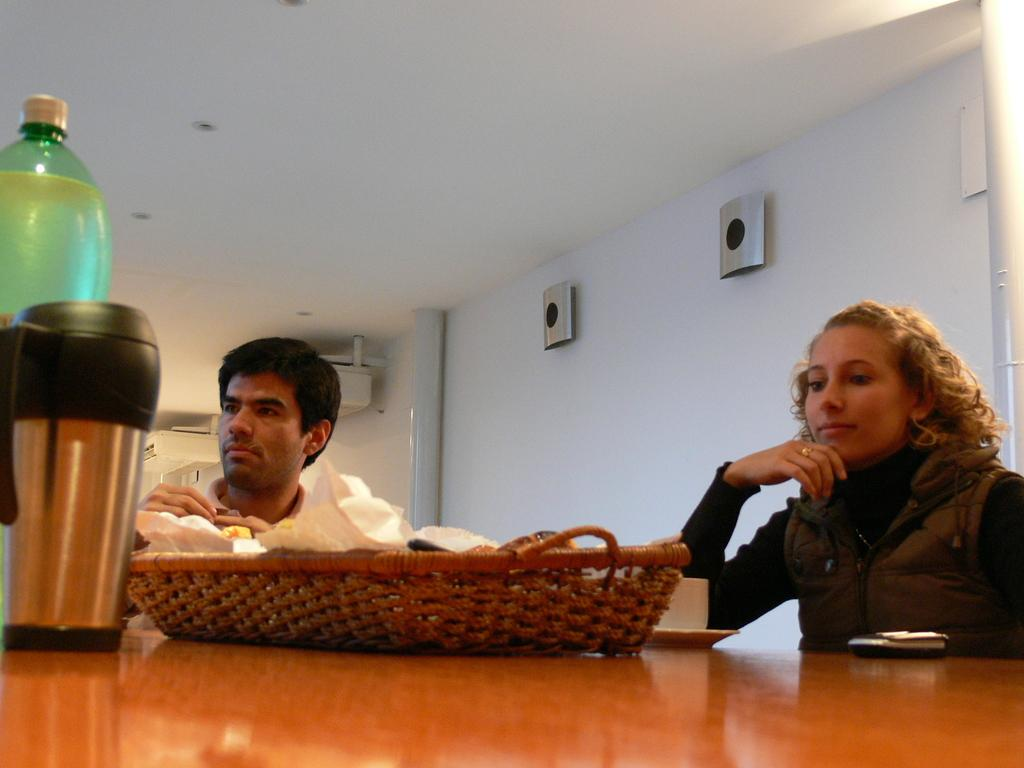How many people are in the image? There is a woman and a man in the image. What are the woman and man doing in the image? The woman and man are sitting beside a table. What objects can be seen on the table in the image? There is a tray, a flask, a bottle, and a cup on the table. What is visible in the background of the image? There is a wall visible in the background of the image. What type of soup is being served in the basket in the image? There is no basket or soup present in the image. Is the man wearing a crown in the image? No, the man is not wearing a crown in the image. 